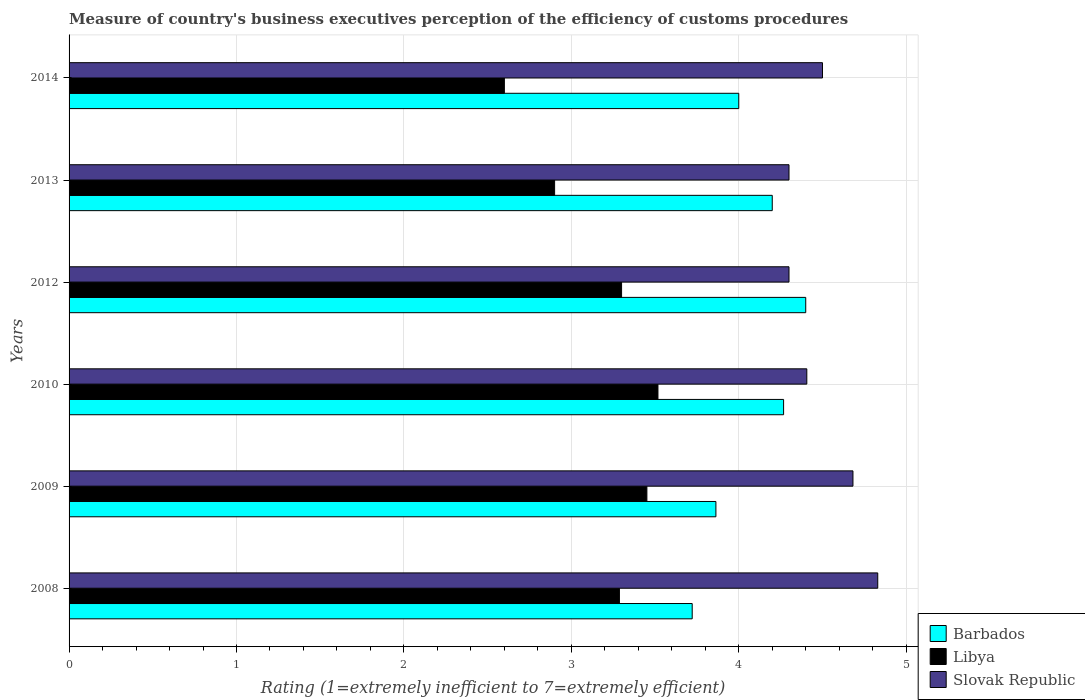How many bars are there on the 6th tick from the top?
Make the answer very short. 3. How many bars are there on the 3rd tick from the bottom?
Provide a succinct answer. 3. What is the rating of the efficiency of customs procedure in Libya in 2010?
Your answer should be very brief. 3.52. Across all years, what is the maximum rating of the efficiency of customs procedure in Libya?
Provide a short and direct response. 3.52. Across all years, what is the minimum rating of the efficiency of customs procedure in Barbados?
Your answer should be compact. 3.72. What is the total rating of the efficiency of customs procedure in Slovak Republic in the graph?
Offer a terse response. 27.02. What is the difference between the rating of the efficiency of customs procedure in Barbados in 2009 and that in 2014?
Your response must be concise. -0.14. What is the difference between the rating of the efficiency of customs procedure in Slovak Republic in 2014 and the rating of the efficiency of customs procedure in Barbados in 2008?
Offer a terse response. 0.78. What is the average rating of the efficiency of customs procedure in Barbados per year?
Make the answer very short. 4.08. What is the ratio of the rating of the efficiency of customs procedure in Libya in 2009 to that in 2010?
Give a very brief answer. 0.98. Is the difference between the rating of the efficiency of customs procedure in Libya in 2012 and 2014 greater than the difference between the rating of the efficiency of customs procedure in Slovak Republic in 2012 and 2014?
Provide a short and direct response. Yes. What is the difference between the highest and the second highest rating of the efficiency of customs procedure in Libya?
Offer a terse response. 0.07. What is the difference between the highest and the lowest rating of the efficiency of customs procedure in Slovak Republic?
Your answer should be very brief. 0.53. In how many years, is the rating of the efficiency of customs procedure in Libya greater than the average rating of the efficiency of customs procedure in Libya taken over all years?
Your answer should be compact. 4. Is the sum of the rating of the efficiency of customs procedure in Slovak Republic in 2009 and 2010 greater than the maximum rating of the efficiency of customs procedure in Libya across all years?
Offer a very short reply. Yes. What does the 1st bar from the top in 2013 represents?
Make the answer very short. Slovak Republic. What does the 2nd bar from the bottom in 2008 represents?
Make the answer very short. Libya. Are all the bars in the graph horizontal?
Make the answer very short. Yes. How many years are there in the graph?
Your answer should be very brief. 6. What is the difference between two consecutive major ticks on the X-axis?
Provide a short and direct response. 1. Are the values on the major ticks of X-axis written in scientific E-notation?
Offer a terse response. No. Does the graph contain any zero values?
Ensure brevity in your answer.  No. Where does the legend appear in the graph?
Make the answer very short. Bottom right. How many legend labels are there?
Ensure brevity in your answer.  3. How are the legend labels stacked?
Your answer should be very brief. Vertical. What is the title of the graph?
Make the answer very short. Measure of country's business executives perception of the efficiency of customs procedures. Does "Congo (Democratic)" appear as one of the legend labels in the graph?
Offer a terse response. No. What is the label or title of the X-axis?
Offer a terse response. Rating (1=extremely inefficient to 7=extremely efficient). What is the label or title of the Y-axis?
Make the answer very short. Years. What is the Rating (1=extremely inefficient to 7=extremely efficient) in Barbados in 2008?
Your answer should be very brief. 3.72. What is the Rating (1=extremely inefficient to 7=extremely efficient) in Libya in 2008?
Ensure brevity in your answer.  3.29. What is the Rating (1=extremely inefficient to 7=extremely efficient) in Slovak Republic in 2008?
Your response must be concise. 4.83. What is the Rating (1=extremely inefficient to 7=extremely efficient) in Barbados in 2009?
Offer a terse response. 3.86. What is the Rating (1=extremely inefficient to 7=extremely efficient) in Libya in 2009?
Your answer should be very brief. 3.45. What is the Rating (1=extremely inefficient to 7=extremely efficient) in Slovak Republic in 2009?
Your response must be concise. 4.68. What is the Rating (1=extremely inefficient to 7=extremely efficient) in Barbados in 2010?
Your answer should be very brief. 4.27. What is the Rating (1=extremely inefficient to 7=extremely efficient) of Libya in 2010?
Offer a terse response. 3.52. What is the Rating (1=extremely inefficient to 7=extremely efficient) in Slovak Republic in 2010?
Offer a very short reply. 4.41. What is the Rating (1=extremely inefficient to 7=extremely efficient) of Slovak Republic in 2013?
Keep it short and to the point. 4.3. What is the Rating (1=extremely inefficient to 7=extremely efficient) of Libya in 2014?
Keep it short and to the point. 2.6. What is the Rating (1=extremely inefficient to 7=extremely efficient) of Slovak Republic in 2014?
Your answer should be very brief. 4.5. Across all years, what is the maximum Rating (1=extremely inefficient to 7=extremely efficient) of Libya?
Make the answer very short. 3.52. Across all years, what is the maximum Rating (1=extremely inefficient to 7=extremely efficient) of Slovak Republic?
Keep it short and to the point. 4.83. Across all years, what is the minimum Rating (1=extremely inefficient to 7=extremely efficient) of Barbados?
Keep it short and to the point. 3.72. Across all years, what is the minimum Rating (1=extremely inefficient to 7=extremely efficient) of Slovak Republic?
Your response must be concise. 4.3. What is the total Rating (1=extremely inefficient to 7=extremely efficient) of Barbados in the graph?
Your response must be concise. 24.45. What is the total Rating (1=extremely inefficient to 7=extremely efficient) of Libya in the graph?
Your answer should be very brief. 19.06. What is the total Rating (1=extremely inefficient to 7=extremely efficient) in Slovak Republic in the graph?
Ensure brevity in your answer.  27.02. What is the difference between the Rating (1=extremely inefficient to 7=extremely efficient) of Barbados in 2008 and that in 2009?
Offer a terse response. -0.14. What is the difference between the Rating (1=extremely inefficient to 7=extremely efficient) of Libya in 2008 and that in 2009?
Your answer should be compact. -0.16. What is the difference between the Rating (1=extremely inefficient to 7=extremely efficient) in Slovak Republic in 2008 and that in 2009?
Offer a terse response. 0.15. What is the difference between the Rating (1=extremely inefficient to 7=extremely efficient) in Barbados in 2008 and that in 2010?
Ensure brevity in your answer.  -0.55. What is the difference between the Rating (1=extremely inefficient to 7=extremely efficient) of Libya in 2008 and that in 2010?
Your answer should be compact. -0.23. What is the difference between the Rating (1=extremely inefficient to 7=extremely efficient) of Slovak Republic in 2008 and that in 2010?
Provide a short and direct response. 0.42. What is the difference between the Rating (1=extremely inefficient to 7=extremely efficient) of Barbados in 2008 and that in 2012?
Your answer should be very brief. -0.68. What is the difference between the Rating (1=extremely inefficient to 7=extremely efficient) of Libya in 2008 and that in 2012?
Offer a very short reply. -0.01. What is the difference between the Rating (1=extremely inefficient to 7=extremely efficient) of Slovak Republic in 2008 and that in 2012?
Your answer should be very brief. 0.53. What is the difference between the Rating (1=extremely inefficient to 7=extremely efficient) in Barbados in 2008 and that in 2013?
Offer a terse response. -0.48. What is the difference between the Rating (1=extremely inefficient to 7=extremely efficient) in Libya in 2008 and that in 2013?
Offer a terse response. 0.39. What is the difference between the Rating (1=extremely inefficient to 7=extremely efficient) of Slovak Republic in 2008 and that in 2013?
Your answer should be compact. 0.53. What is the difference between the Rating (1=extremely inefficient to 7=extremely efficient) of Barbados in 2008 and that in 2014?
Offer a very short reply. -0.28. What is the difference between the Rating (1=extremely inefficient to 7=extremely efficient) in Libya in 2008 and that in 2014?
Keep it short and to the point. 0.69. What is the difference between the Rating (1=extremely inefficient to 7=extremely efficient) of Slovak Republic in 2008 and that in 2014?
Your answer should be very brief. 0.33. What is the difference between the Rating (1=extremely inefficient to 7=extremely efficient) in Barbados in 2009 and that in 2010?
Your answer should be very brief. -0.4. What is the difference between the Rating (1=extremely inefficient to 7=extremely efficient) of Libya in 2009 and that in 2010?
Provide a short and direct response. -0.07. What is the difference between the Rating (1=extremely inefficient to 7=extremely efficient) in Slovak Republic in 2009 and that in 2010?
Offer a very short reply. 0.28. What is the difference between the Rating (1=extremely inefficient to 7=extremely efficient) of Barbados in 2009 and that in 2012?
Offer a terse response. -0.54. What is the difference between the Rating (1=extremely inefficient to 7=extremely efficient) in Libya in 2009 and that in 2012?
Provide a succinct answer. 0.15. What is the difference between the Rating (1=extremely inefficient to 7=extremely efficient) in Slovak Republic in 2009 and that in 2012?
Offer a very short reply. 0.38. What is the difference between the Rating (1=extremely inefficient to 7=extremely efficient) of Barbados in 2009 and that in 2013?
Provide a short and direct response. -0.34. What is the difference between the Rating (1=extremely inefficient to 7=extremely efficient) of Libya in 2009 and that in 2013?
Your answer should be compact. 0.55. What is the difference between the Rating (1=extremely inefficient to 7=extremely efficient) of Slovak Republic in 2009 and that in 2013?
Keep it short and to the point. 0.38. What is the difference between the Rating (1=extremely inefficient to 7=extremely efficient) of Barbados in 2009 and that in 2014?
Offer a terse response. -0.14. What is the difference between the Rating (1=extremely inefficient to 7=extremely efficient) of Libya in 2009 and that in 2014?
Your answer should be very brief. 0.85. What is the difference between the Rating (1=extremely inefficient to 7=extremely efficient) in Slovak Republic in 2009 and that in 2014?
Give a very brief answer. 0.18. What is the difference between the Rating (1=extremely inefficient to 7=extremely efficient) in Barbados in 2010 and that in 2012?
Give a very brief answer. -0.13. What is the difference between the Rating (1=extremely inefficient to 7=extremely efficient) of Libya in 2010 and that in 2012?
Provide a short and direct response. 0.22. What is the difference between the Rating (1=extremely inefficient to 7=extremely efficient) of Slovak Republic in 2010 and that in 2012?
Offer a terse response. 0.11. What is the difference between the Rating (1=extremely inefficient to 7=extremely efficient) in Barbados in 2010 and that in 2013?
Offer a terse response. 0.07. What is the difference between the Rating (1=extremely inefficient to 7=extremely efficient) in Libya in 2010 and that in 2013?
Give a very brief answer. 0.62. What is the difference between the Rating (1=extremely inefficient to 7=extremely efficient) in Slovak Republic in 2010 and that in 2013?
Your answer should be compact. 0.11. What is the difference between the Rating (1=extremely inefficient to 7=extremely efficient) of Barbados in 2010 and that in 2014?
Your response must be concise. 0.27. What is the difference between the Rating (1=extremely inefficient to 7=extremely efficient) of Libya in 2010 and that in 2014?
Your response must be concise. 0.92. What is the difference between the Rating (1=extremely inefficient to 7=extremely efficient) in Slovak Republic in 2010 and that in 2014?
Your answer should be very brief. -0.09. What is the difference between the Rating (1=extremely inefficient to 7=extremely efficient) of Libya in 2012 and that in 2013?
Keep it short and to the point. 0.4. What is the difference between the Rating (1=extremely inefficient to 7=extremely efficient) in Slovak Republic in 2012 and that in 2013?
Offer a very short reply. 0. What is the difference between the Rating (1=extremely inefficient to 7=extremely efficient) of Libya in 2012 and that in 2014?
Give a very brief answer. 0.7. What is the difference between the Rating (1=extremely inefficient to 7=extremely efficient) in Barbados in 2013 and that in 2014?
Provide a short and direct response. 0.2. What is the difference between the Rating (1=extremely inefficient to 7=extremely efficient) of Barbados in 2008 and the Rating (1=extremely inefficient to 7=extremely efficient) of Libya in 2009?
Give a very brief answer. 0.27. What is the difference between the Rating (1=extremely inefficient to 7=extremely efficient) of Barbados in 2008 and the Rating (1=extremely inefficient to 7=extremely efficient) of Slovak Republic in 2009?
Offer a terse response. -0.96. What is the difference between the Rating (1=extremely inefficient to 7=extremely efficient) in Libya in 2008 and the Rating (1=extremely inefficient to 7=extremely efficient) in Slovak Republic in 2009?
Ensure brevity in your answer.  -1.39. What is the difference between the Rating (1=extremely inefficient to 7=extremely efficient) in Barbados in 2008 and the Rating (1=extremely inefficient to 7=extremely efficient) in Libya in 2010?
Ensure brevity in your answer.  0.2. What is the difference between the Rating (1=extremely inefficient to 7=extremely efficient) of Barbados in 2008 and the Rating (1=extremely inefficient to 7=extremely efficient) of Slovak Republic in 2010?
Offer a very short reply. -0.68. What is the difference between the Rating (1=extremely inefficient to 7=extremely efficient) in Libya in 2008 and the Rating (1=extremely inefficient to 7=extremely efficient) in Slovak Republic in 2010?
Provide a short and direct response. -1.12. What is the difference between the Rating (1=extremely inefficient to 7=extremely efficient) in Barbados in 2008 and the Rating (1=extremely inefficient to 7=extremely efficient) in Libya in 2012?
Your answer should be very brief. 0.42. What is the difference between the Rating (1=extremely inefficient to 7=extremely efficient) of Barbados in 2008 and the Rating (1=extremely inefficient to 7=extremely efficient) of Slovak Republic in 2012?
Your answer should be compact. -0.58. What is the difference between the Rating (1=extremely inefficient to 7=extremely efficient) in Libya in 2008 and the Rating (1=extremely inefficient to 7=extremely efficient) in Slovak Republic in 2012?
Your response must be concise. -1.01. What is the difference between the Rating (1=extremely inefficient to 7=extremely efficient) of Barbados in 2008 and the Rating (1=extremely inefficient to 7=extremely efficient) of Libya in 2013?
Keep it short and to the point. 0.82. What is the difference between the Rating (1=extremely inefficient to 7=extremely efficient) in Barbados in 2008 and the Rating (1=extremely inefficient to 7=extremely efficient) in Slovak Republic in 2013?
Provide a short and direct response. -0.58. What is the difference between the Rating (1=extremely inefficient to 7=extremely efficient) of Libya in 2008 and the Rating (1=extremely inefficient to 7=extremely efficient) of Slovak Republic in 2013?
Your answer should be very brief. -1.01. What is the difference between the Rating (1=extremely inefficient to 7=extremely efficient) of Barbados in 2008 and the Rating (1=extremely inefficient to 7=extremely efficient) of Libya in 2014?
Keep it short and to the point. 1.12. What is the difference between the Rating (1=extremely inefficient to 7=extremely efficient) in Barbados in 2008 and the Rating (1=extremely inefficient to 7=extremely efficient) in Slovak Republic in 2014?
Provide a succinct answer. -0.78. What is the difference between the Rating (1=extremely inefficient to 7=extremely efficient) of Libya in 2008 and the Rating (1=extremely inefficient to 7=extremely efficient) of Slovak Republic in 2014?
Ensure brevity in your answer.  -1.21. What is the difference between the Rating (1=extremely inefficient to 7=extremely efficient) in Barbados in 2009 and the Rating (1=extremely inefficient to 7=extremely efficient) in Libya in 2010?
Provide a short and direct response. 0.35. What is the difference between the Rating (1=extremely inefficient to 7=extremely efficient) in Barbados in 2009 and the Rating (1=extremely inefficient to 7=extremely efficient) in Slovak Republic in 2010?
Your answer should be compact. -0.54. What is the difference between the Rating (1=extremely inefficient to 7=extremely efficient) of Libya in 2009 and the Rating (1=extremely inefficient to 7=extremely efficient) of Slovak Republic in 2010?
Your answer should be very brief. -0.96. What is the difference between the Rating (1=extremely inefficient to 7=extremely efficient) of Barbados in 2009 and the Rating (1=extremely inefficient to 7=extremely efficient) of Libya in 2012?
Make the answer very short. 0.56. What is the difference between the Rating (1=extremely inefficient to 7=extremely efficient) in Barbados in 2009 and the Rating (1=extremely inefficient to 7=extremely efficient) in Slovak Republic in 2012?
Make the answer very short. -0.44. What is the difference between the Rating (1=extremely inefficient to 7=extremely efficient) in Libya in 2009 and the Rating (1=extremely inefficient to 7=extremely efficient) in Slovak Republic in 2012?
Ensure brevity in your answer.  -0.85. What is the difference between the Rating (1=extremely inefficient to 7=extremely efficient) of Barbados in 2009 and the Rating (1=extremely inefficient to 7=extremely efficient) of Libya in 2013?
Offer a very short reply. 0.96. What is the difference between the Rating (1=extremely inefficient to 7=extremely efficient) of Barbados in 2009 and the Rating (1=extremely inefficient to 7=extremely efficient) of Slovak Republic in 2013?
Provide a succinct answer. -0.44. What is the difference between the Rating (1=extremely inefficient to 7=extremely efficient) of Libya in 2009 and the Rating (1=extremely inefficient to 7=extremely efficient) of Slovak Republic in 2013?
Offer a terse response. -0.85. What is the difference between the Rating (1=extremely inefficient to 7=extremely efficient) in Barbados in 2009 and the Rating (1=extremely inefficient to 7=extremely efficient) in Libya in 2014?
Give a very brief answer. 1.26. What is the difference between the Rating (1=extremely inefficient to 7=extremely efficient) in Barbados in 2009 and the Rating (1=extremely inefficient to 7=extremely efficient) in Slovak Republic in 2014?
Offer a terse response. -0.64. What is the difference between the Rating (1=extremely inefficient to 7=extremely efficient) of Libya in 2009 and the Rating (1=extremely inefficient to 7=extremely efficient) of Slovak Republic in 2014?
Give a very brief answer. -1.05. What is the difference between the Rating (1=extremely inefficient to 7=extremely efficient) in Barbados in 2010 and the Rating (1=extremely inefficient to 7=extremely efficient) in Slovak Republic in 2012?
Offer a terse response. -0.03. What is the difference between the Rating (1=extremely inefficient to 7=extremely efficient) in Libya in 2010 and the Rating (1=extremely inefficient to 7=extremely efficient) in Slovak Republic in 2012?
Offer a very short reply. -0.78. What is the difference between the Rating (1=extremely inefficient to 7=extremely efficient) of Barbados in 2010 and the Rating (1=extremely inefficient to 7=extremely efficient) of Libya in 2013?
Ensure brevity in your answer.  1.37. What is the difference between the Rating (1=extremely inefficient to 7=extremely efficient) in Barbados in 2010 and the Rating (1=extremely inefficient to 7=extremely efficient) in Slovak Republic in 2013?
Make the answer very short. -0.03. What is the difference between the Rating (1=extremely inefficient to 7=extremely efficient) of Libya in 2010 and the Rating (1=extremely inefficient to 7=extremely efficient) of Slovak Republic in 2013?
Your answer should be very brief. -0.78. What is the difference between the Rating (1=extremely inefficient to 7=extremely efficient) of Barbados in 2010 and the Rating (1=extremely inefficient to 7=extremely efficient) of Libya in 2014?
Your answer should be compact. 1.67. What is the difference between the Rating (1=extremely inefficient to 7=extremely efficient) of Barbados in 2010 and the Rating (1=extremely inefficient to 7=extremely efficient) of Slovak Republic in 2014?
Ensure brevity in your answer.  -0.23. What is the difference between the Rating (1=extremely inefficient to 7=extremely efficient) of Libya in 2010 and the Rating (1=extremely inefficient to 7=extremely efficient) of Slovak Republic in 2014?
Make the answer very short. -0.98. What is the difference between the Rating (1=extremely inefficient to 7=extremely efficient) in Barbados in 2012 and the Rating (1=extremely inefficient to 7=extremely efficient) in Libya in 2013?
Make the answer very short. 1.5. What is the difference between the Rating (1=extremely inefficient to 7=extremely efficient) of Barbados in 2013 and the Rating (1=extremely inefficient to 7=extremely efficient) of Libya in 2014?
Your response must be concise. 1.6. What is the difference between the Rating (1=extremely inefficient to 7=extremely efficient) of Barbados in 2013 and the Rating (1=extremely inefficient to 7=extremely efficient) of Slovak Republic in 2014?
Make the answer very short. -0.3. What is the difference between the Rating (1=extremely inefficient to 7=extremely efficient) in Libya in 2013 and the Rating (1=extremely inefficient to 7=extremely efficient) in Slovak Republic in 2014?
Offer a very short reply. -1.6. What is the average Rating (1=extremely inefficient to 7=extremely efficient) of Barbados per year?
Keep it short and to the point. 4.08. What is the average Rating (1=extremely inefficient to 7=extremely efficient) in Libya per year?
Give a very brief answer. 3.18. What is the average Rating (1=extremely inefficient to 7=extremely efficient) in Slovak Republic per year?
Ensure brevity in your answer.  4.5. In the year 2008, what is the difference between the Rating (1=extremely inefficient to 7=extremely efficient) in Barbados and Rating (1=extremely inefficient to 7=extremely efficient) in Libya?
Provide a succinct answer. 0.43. In the year 2008, what is the difference between the Rating (1=extremely inefficient to 7=extremely efficient) of Barbados and Rating (1=extremely inefficient to 7=extremely efficient) of Slovak Republic?
Your response must be concise. -1.11. In the year 2008, what is the difference between the Rating (1=extremely inefficient to 7=extremely efficient) of Libya and Rating (1=extremely inefficient to 7=extremely efficient) of Slovak Republic?
Ensure brevity in your answer.  -1.54. In the year 2009, what is the difference between the Rating (1=extremely inefficient to 7=extremely efficient) in Barbados and Rating (1=extremely inefficient to 7=extremely efficient) in Libya?
Offer a very short reply. 0.41. In the year 2009, what is the difference between the Rating (1=extremely inefficient to 7=extremely efficient) of Barbados and Rating (1=extremely inefficient to 7=extremely efficient) of Slovak Republic?
Your answer should be compact. -0.82. In the year 2009, what is the difference between the Rating (1=extremely inefficient to 7=extremely efficient) of Libya and Rating (1=extremely inefficient to 7=extremely efficient) of Slovak Republic?
Offer a very short reply. -1.23. In the year 2010, what is the difference between the Rating (1=extremely inefficient to 7=extremely efficient) of Barbados and Rating (1=extremely inefficient to 7=extremely efficient) of Libya?
Offer a terse response. 0.75. In the year 2010, what is the difference between the Rating (1=extremely inefficient to 7=extremely efficient) of Barbados and Rating (1=extremely inefficient to 7=extremely efficient) of Slovak Republic?
Provide a succinct answer. -0.14. In the year 2010, what is the difference between the Rating (1=extremely inefficient to 7=extremely efficient) in Libya and Rating (1=extremely inefficient to 7=extremely efficient) in Slovak Republic?
Provide a succinct answer. -0.89. In the year 2012, what is the difference between the Rating (1=extremely inefficient to 7=extremely efficient) in Barbados and Rating (1=extremely inefficient to 7=extremely efficient) in Slovak Republic?
Provide a succinct answer. 0.1. In the year 2014, what is the difference between the Rating (1=extremely inefficient to 7=extremely efficient) of Barbados and Rating (1=extremely inefficient to 7=extremely efficient) of Slovak Republic?
Offer a terse response. -0.5. What is the ratio of the Rating (1=extremely inefficient to 7=extremely efficient) in Barbados in 2008 to that in 2009?
Offer a terse response. 0.96. What is the ratio of the Rating (1=extremely inefficient to 7=extremely efficient) in Libya in 2008 to that in 2009?
Your answer should be compact. 0.95. What is the ratio of the Rating (1=extremely inefficient to 7=extremely efficient) of Slovak Republic in 2008 to that in 2009?
Provide a succinct answer. 1.03. What is the ratio of the Rating (1=extremely inefficient to 7=extremely efficient) in Barbados in 2008 to that in 2010?
Provide a succinct answer. 0.87. What is the ratio of the Rating (1=extremely inefficient to 7=extremely efficient) in Libya in 2008 to that in 2010?
Your answer should be very brief. 0.93. What is the ratio of the Rating (1=extremely inefficient to 7=extremely efficient) of Slovak Republic in 2008 to that in 2010?
Your answer should be very brief. 1.1. What is the ratio of the Rating (1=extremely inefficient to 7=extremely efficient) of Barbados in 2008 to that in 2012?
Keep it short and to the point. 0.85. What is the ratio of the Rating (1=extremely inefficient to 7=extremely efficient) in Slovak Republic in 2008 to that in 2012?
Your response must be concise. 1.12. What is the ratio of the Rating (1=extremely inefficient to 7=extremely efficient) in Barbados in 2008 to that in 2013?
Make the answer very short. 0.89. What is the ratio of the Rating (1=extremely inefficient to 7=extremely efficient) in Libya in 2008 to that in 2013?
Your answer should be very brief. 1.13. What is the ratio of the Rating (1=extremely inefficient to 7=extremely efficient) of Slovak Republic in 2008 to that in 2013?
Provide a succinct answer. 1.12. What is the ratio of the Rating (1=extremely inefficient to 7=extremely efficient) in Barbados in 2008 to that in 2014?
Make the answer very short. 0.93. What is the ratio of the Rating (1=extremely inefficient to 7=extremely efficient) in Libya in 2008 to that in 2014?
Your answer should be compact. 1.26. What is the ratio of the Rating (1=extremely inefficient to 7=extremely efficient) in Slovak Republic in 2008 to that in 2014?
Ensure brevity in your answer.  1.07. What is the ratio of the Rating (1=extremely inefficient to 7=extremely efficient) of Barbados in 2009 to that in 2010?
Your response must be concise. 0.91. What is the ratio of the Rating (1=extremely inefficient to 7=extremely efficient) of Libya in 2009 to that in 2010?
Provide a succinct answer. 0.98. What is the ratio of the Rating (1=extremely inefficient to 7=extremely efficient) of Slovak Republic in 2009 to that in 2010?
Ensure brevity in your answer.  1.06. What is the ratio of the Rating (1=extremely inefficient to 7=extremely efficient) in Barbados in 2009 to that in 2012?
Your answer should be very brief. 0.88. What is the ratio of the Rating (1=extremely inefficient to 7=extremely efficient) of Libya in 2009 to that in 2012?
Your response must be concise. 1.05. What is the ratio of the Rating (1=extremely inefficient to 7=extremely efficient) in Slovak Republic in 2009 to that in 2012?
Your answer should be compact. 1.09. What is the ratio of the Rating (1=extremely inefficient to 7=extremely efficient) in Barbados in 2009 to that in 2013?
Provide a short and direct response. 0.92. What is the ratio of the Rating (1=extremely inefficient to 7=extremely efficient) of Libya in 2009 to that in 2013?
Offer a terse response. 1.19. What is the ratio of the Rating (1=extremely inefficient to 7=extremely efficient) in Slovak Republic in 2009 to that in 2013?
Offer a very short reply. 1.09. What is the ratio of the Rating (1=extremely inefficient to 7=extremely efficient) in Barbados in 2009 to that in 2014?
Your answer should be very brief. 0.97. What is the ratio of the Rating (1=extremely inefficient to 7=extremely efficient) in Libya in 2009 to that in 2014?
Provide a short and direct response. 1.33. What is the ratio of the Rating (1=extremely inefficient to 7=extremely efficient) in Slovak Republic in 2009 to that in 2014?
Provide a succinct answer. 1.04. What is the ratio of the Rating (1=extremely inefficient to 7=extremely efficient) in Barbados in 2010 to that in 2012?
Your answer should be very brief. 0.97. What is the ratio of the Rating (1=extremely inefficient to 7=extremely efficient) of Libya in 2010 to that in 2012?
Make the answer very short. 1.07. What is the ratio of the Rating (1=extremely inefficient to 7=extremely efficient) in Slovak Republic in 2010 to that in 2012?
Your answer should be very brief. 1.02. What is the ratio of the Rating (1=extremely inefficient to 7=extremely efficient) of Barbados in 2010 to that in 2013?
Offer a very short reply. 1.02. What is the ratio of the Rating (1=extremely inefficient to 7=extremely efficient) of Libya in 2010 to that in 2013?
Your answer should be very brief. 1.21. What is the ratio of the Rating (1=extremely inefficient to 7=extremely efficient) in Slovak Republic in 2010 to that in 2013?
Provide a succinct answer. 1.02. What is the ratio of the Rating (1=extremely inefficient to 7=extremely efficient) in Barbados in 2010 to that in 2014?
Offer a terse response. 1.07. What is the ratio of the Rating (1=extremely inefficient to 7=extremely efficient) in Libya in 2010 to that in 2014?
Your answer should be compact. 1.35. What is the ratio of the Rating (1=extremely inefficient to 7=extremely efficient) in Slovak Republic in 2010 to that in 2014?
Make the answer very short. 0.98. What is the ratio of the Rating (1=extremely inefficient to 7=extremely efficient) in Barbados in 2012 to that in 2013?
Make the answer very short. 1.05. What is the ratio of the Rating (1=extremely inefficient to 7=extremely efficient) in Libya in 2012 to that in 2013?
Keep it short and to the point. 1.14. What is the ratio of the Rating (1=extremely inefficient to 7=extremely efficient) of Barbados in 2012 to that in 2014?
Ensure brevity in your answer.  1.1. What is the ratio of the Rating (1=extremely inefficient to 7=extremely efficient) of Libya in 2012 to that in 2014?
Offer a terse response. 1.27. What is the ratio of the Rating (1=extremely inefficient to 7=extremely efficient) of Slovak Republic in 2012 to that in 2014?
Your answer should be compact. 0.96. What is the ratio of the Rating (1=extremely inefficient to 7=extremely efficient) in Libya in 2013 to that in 2014?
Give a very brief answer. 1.12. What is the ratio of the Rating (1=extremely inefficient to 7=extremely efficient) in Slovak Republic in 2013 to that in 2014?
Ensure brevity in your answer.  0.96. What is the difference between the highest and the second highest Rating (1=extremely inefficient to 7=extremely efficient) of Barbados?
Ensure brevity in your answer.  0.13. What is the difference between the highest and the second highest Rating (1=extremely inefficient to 7=extremely efficient) in Libya?
Your response must be concise. 0.07. What is the difference between the highest and the second highest Rating (1=extremely inefficient to 7=extremely efficient) in Slovak Republic?
Offer a very short reply. 0.15. What is the difference between the highest and the lowest Rating (1=extremely inefficient to 7=extremely efficient) in Barbados?
Your response must be concise. 0.68. What is the difference between the highest and the lowest Rating (1=extremely inefficient to 7=extremely efficient) of Libya?
Make the answer very short. 0.92. What is the difference between the highest and the lowest Rating (1=extremely inefficient to 7=extremely efficient) in Slovak Republic?
Offer a very short reply. 0.53. 